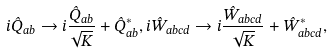Convert formula to latex. <formula><loc_0><loc_0><loc_500><loc_500>i \hat { Q } _ { a b } \rightarrow i \frac { \hat { Q } _ { a b } } { \sqrt { K } } + \hat { Q } ^ { * } _ { a b } , i \hat { W } _ { a b c d } \rightarrow i \frac { \hat { W } _ { a b c d } } { \sqrt { K } } + \hat { W } ^ { * } _ { a b c d } ,</formula> 